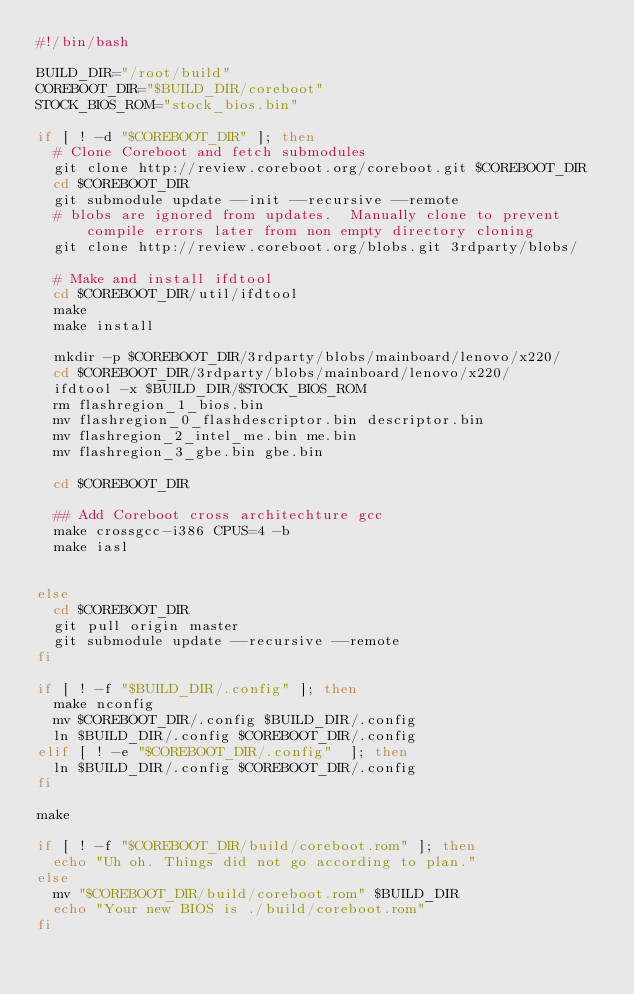<code> <loc_0><loc_0><loc_500><loc_500><_Bash_>#!/bin/bash

BUILD_DIR="/root/build"
COREBOOT_DIR="$BUILD_DIR/coreboot"
STOCK_BIOS_ROM="stock_bios.bin"

if [ ! -d "$COREBOOT_DIR" ]; then
  # Clone Coreboot and fetch submodules
  git clone http://review.coreboot.org/coreboot.git $COREBOOT_DIR
  cd $COREBOOT_DIR
  git submodule update --init --recursive --remote
  # blobs are ignored from updates.  Manually clone to prevent compile errors later from non empty directory cloning
  git clone http://review.coreboot.org/blobs.git 3rdparty/blobs/

  # Make and install ifdtool
  cd $COREBOOT_DIR/util/ifdtool
  make
  make install

  mkdir -p $COREBOOT_DIR/3rdparty/blobs/mainboard/lenovo/x220/
  cd $COREBOOT_DIR/3rdparty/blobs/mainboard/lenovo/x220/
  ifdtool -x $BUILD_DIR/$STOCK_BIOS_ROM
  rm flashregion_1_bios.bin
  mv flashregion_0_flashdescriptor.bin descriptor.bin
  mv flashregion_2_intel_me.bin me.bin
  mv flashregion_3_gbe.bin gbe.bin

  cd $COREBOOT_DIR

  ## Add Coreboot cross architechture gcc
  make crossgcc-i386 CPUS=4 -b
  make iasl


else
  cd $COREBOOT_DIR
  git pull origin master
  git submodule update --recursive --remote
fi

if [ ! -f "$BUILD_DIR/.config" ]; then
  make nconfig
  mv $COREBOOT_DIR/.config $BUILD_DIR/.config
  ln $BUILD_DIR/.config $COREBOOT_DIR/.config
elif [ ! -e "$COREBOOT_DIR/.config"  ]; then
  ln $BUILD_DIR/.config $COREBOOT_DIR/.config
fi

make

if [ ! -f "$COREBOOT_DIR/build/coreboot.rom" ]; then
  echo "Uh oh. Things did not go according to plan."
else
  mv "$COREBOOT_DIR/build/coreboot.rom" $BUILD_DIR
  echo "Your new BIOS is ./build/coreboot.rom"
fi
</code> 